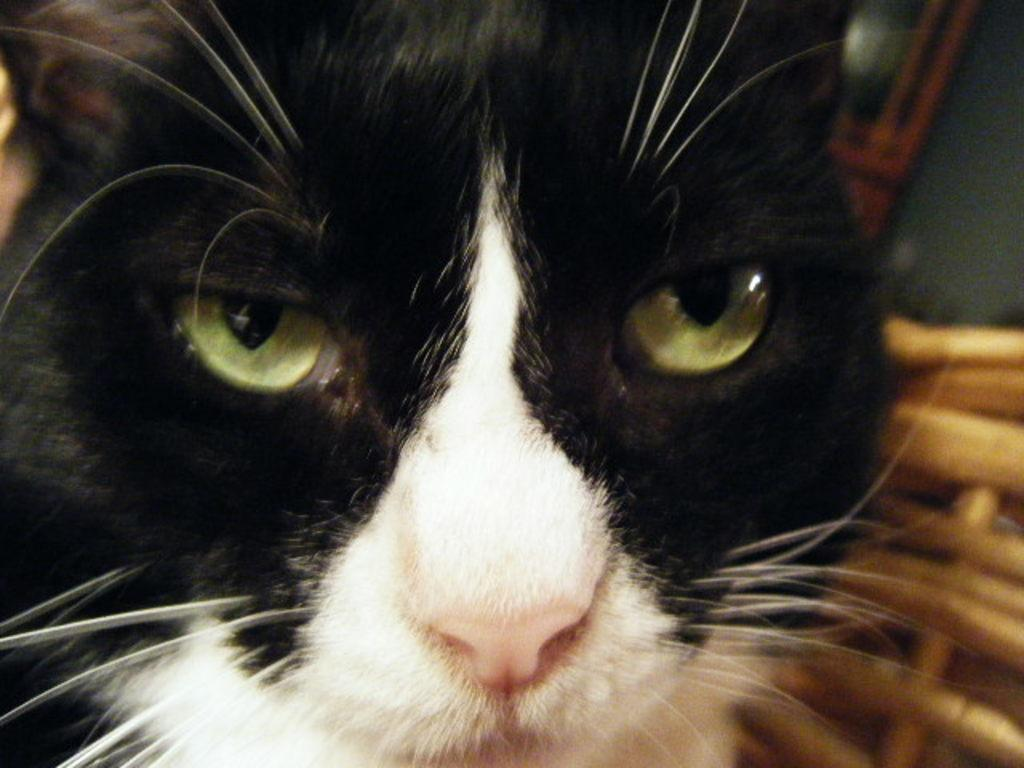What type of animal is present in the image? There is a cat in the image. What type of wall can be seen in the image? There is no wall present in the image; it only features a cat. 